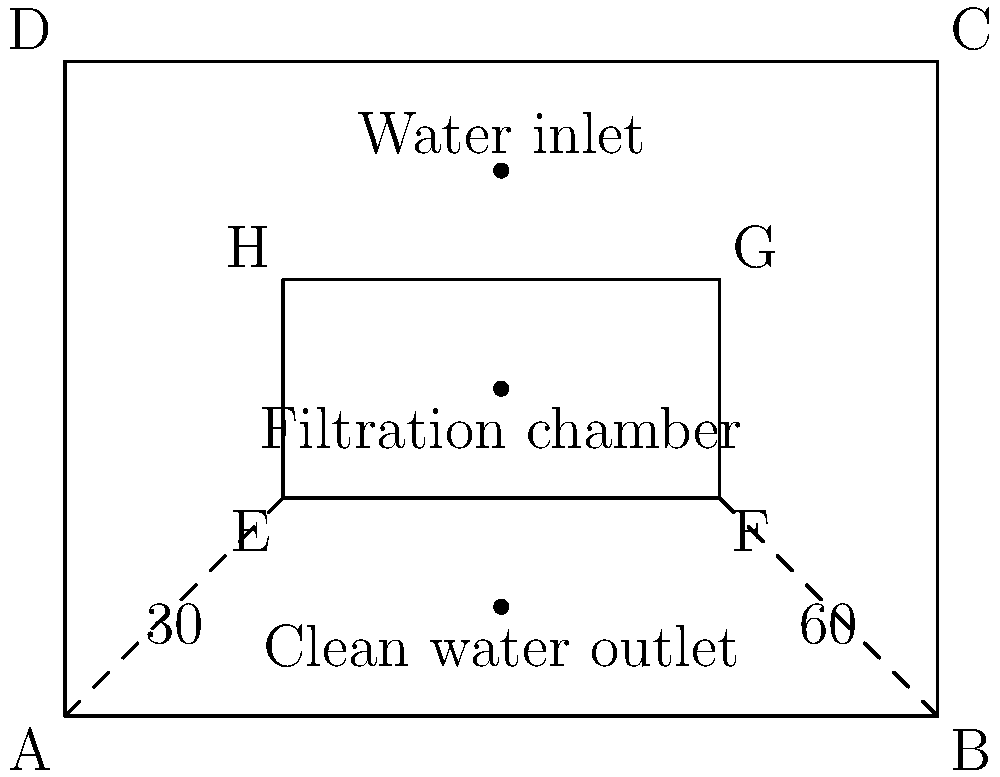In the sustainable water filtration system shown for an animal habitat, the inlet and outlet pipes are angled to optimize water flow and reduce energy consumption. If the inlet pipe forms a 30° angle with the horizontal, what is the angle between the inlet and outlet pipes? To find the angle between the inlet and outlet pipes, we need to follow these steps:

1. Identify the given information:
   - The inlet pipe forms a 30° angle with the horizontal.
   - The outlet pipe forms a 60° angle with the horizontal (as shown in the diagram).

2. Calculate the angle between the pipes:
   - The total angle between the two pipes is the sum of their individual angles from the horizontal.
   - Angle between pipes = Inlet pipe angle + Outlet pipe angle
   - Angle between pipes = 30° + 60° = 90°

3. Verify the result:
   - This 90° angle forms a right angle between the inlet and outlet pipes, which is often used in sustainable designs to maximize gravitational flow and minimize energy use in pumping systems.

Therefore, the angle between the inlet and outlet pipes is 90°.
Answer: 90° 